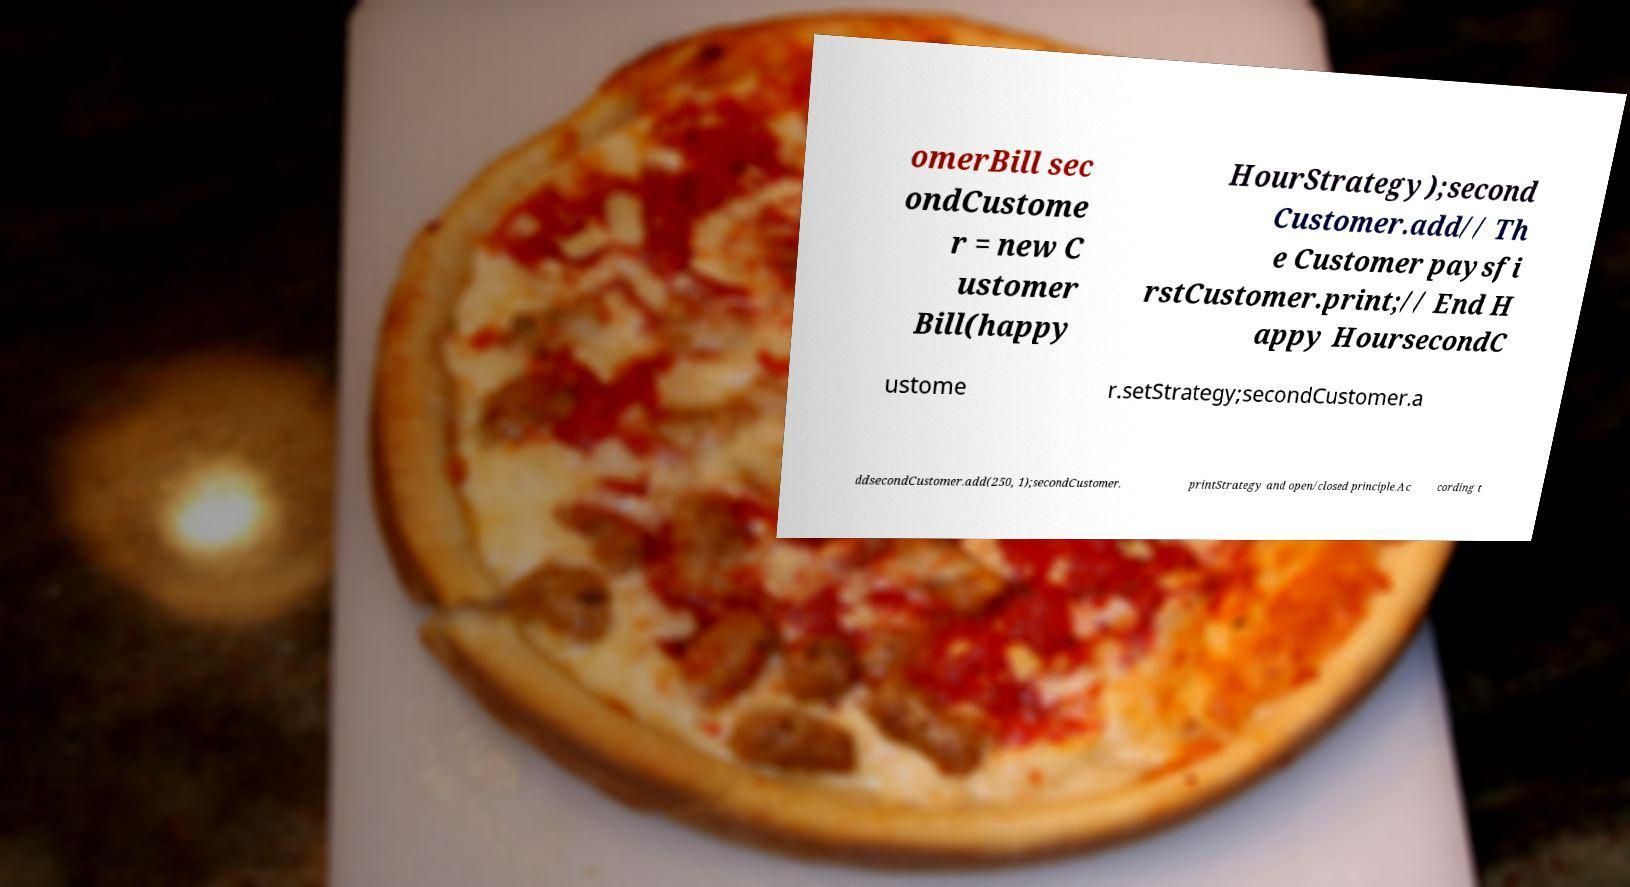Please read and relay the text visible in this image. What does it say? omerBill sec ondCustome r = new C ustomer Bill(happy HourStrategy);second Customer.add// Th e Customer paysfi rstCustomer.print;// End H appy HoursecondC ustome r.setStrategy;secondCustomer.a ddsecondCustomer.add(250, 1);secondCustomer. printStrategy and open/closed principle.Ac cording t 